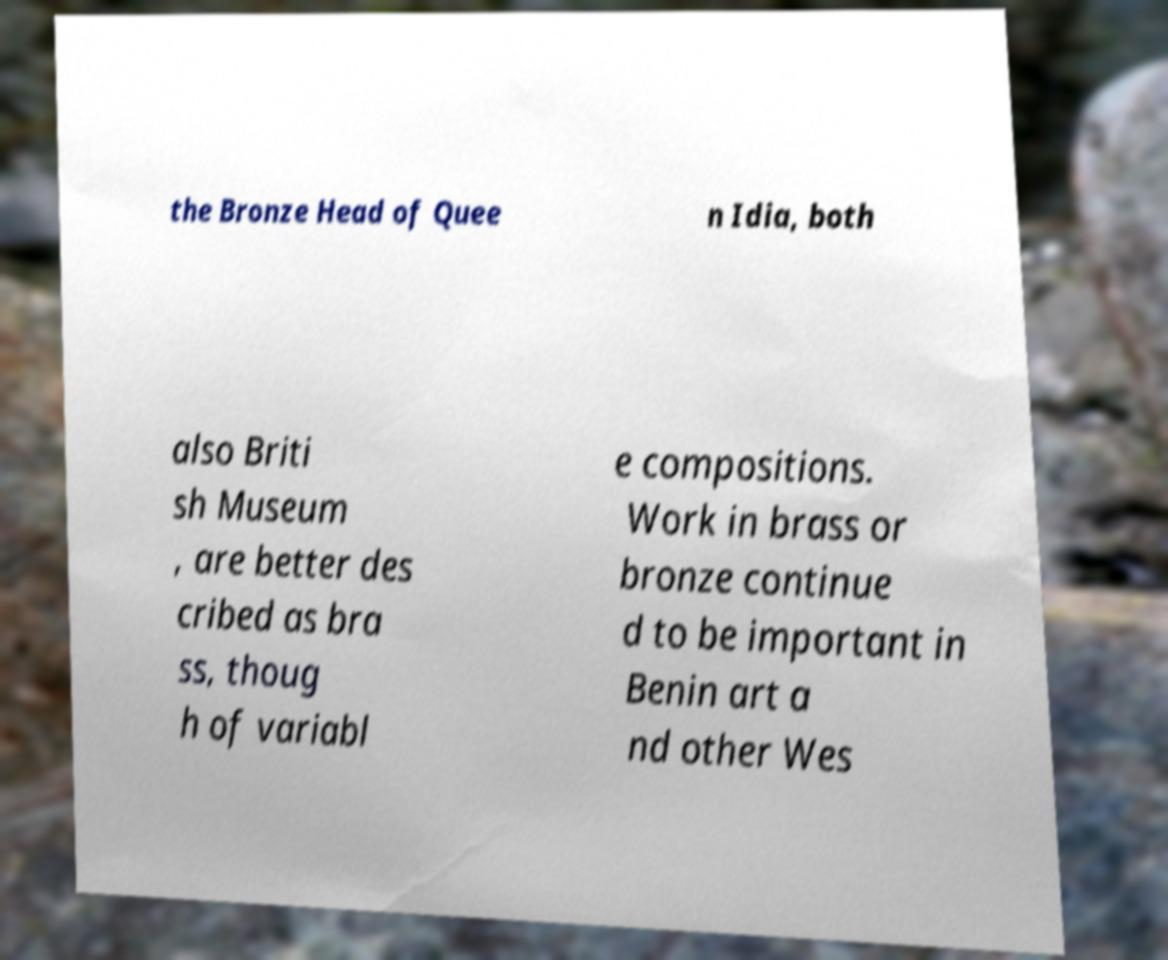Can you accurately transcribe the text from the provided image for me? the Bronze Head of Quee n Idia, both also Briti sh Museum , are better des cribed as bra ss, thoug h of variabl e compositions. Work in brass or bronze continue d to be important in Benin art a nd other Wes 